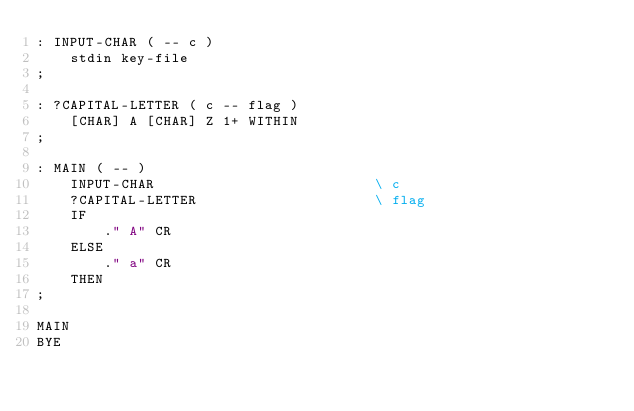Convert code to text. <code><loc_0><loc_0><loc_500><loc_500><_Forth_>: INPUT-CHAR ( -- c )
    stdin key-file
;

: ?CAPITAL-LETTER ( c -- flag )
    [CHAR] A [CHAR] Z 1+ WITHIN
;

: MAIN ( -- )
    INPUT-CHAR                          \ c
    ?CAPITAL-LETTER                     \ flag
    IF
        ." A" CR
    ELSE
        ." a" CR
    THEN
;

MAIN
BYE
</code> 